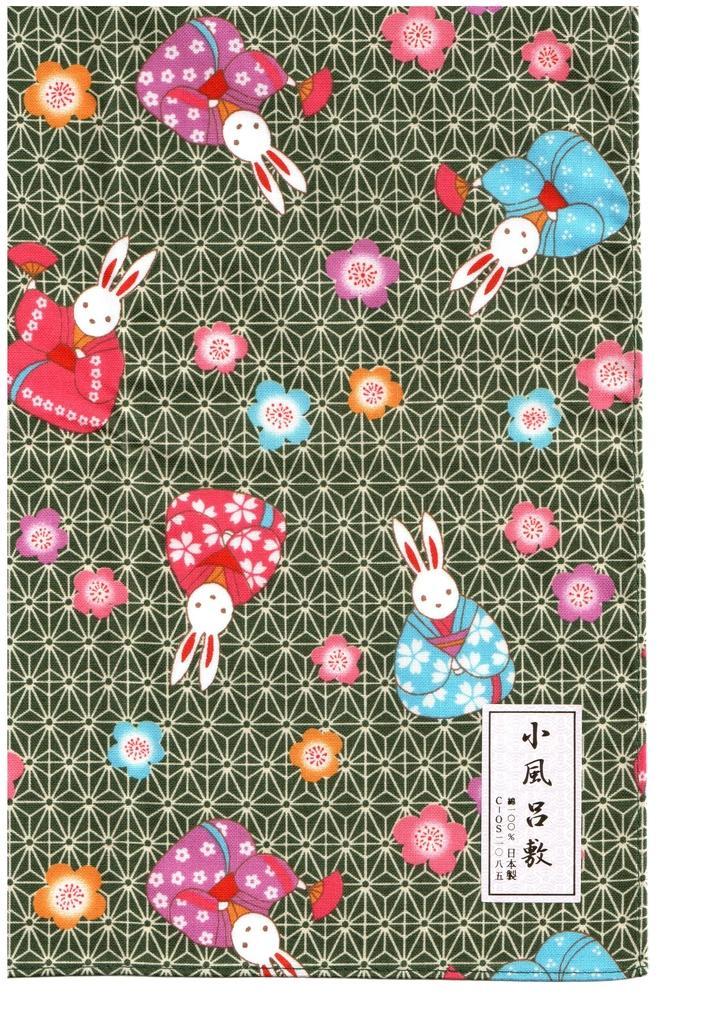Can you describe this image briefly? In the image there are rabbit images. And also there are colorful flowers. And there is a black background with design. On the right side of the image there is a logo. 